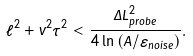Convert formula to latex. <formula><loc_0><loc_0><loc_500><loc_500>\ell ^ { 2 } + v ^ { 2 } { \tau } ^ { 2 } < \frac { \Delta L _ { p r o b e } ^ { 2 } } { 4 \ln { \left ( A / \varepsilon _ { n o i s e } \right ) } } .</formula> 